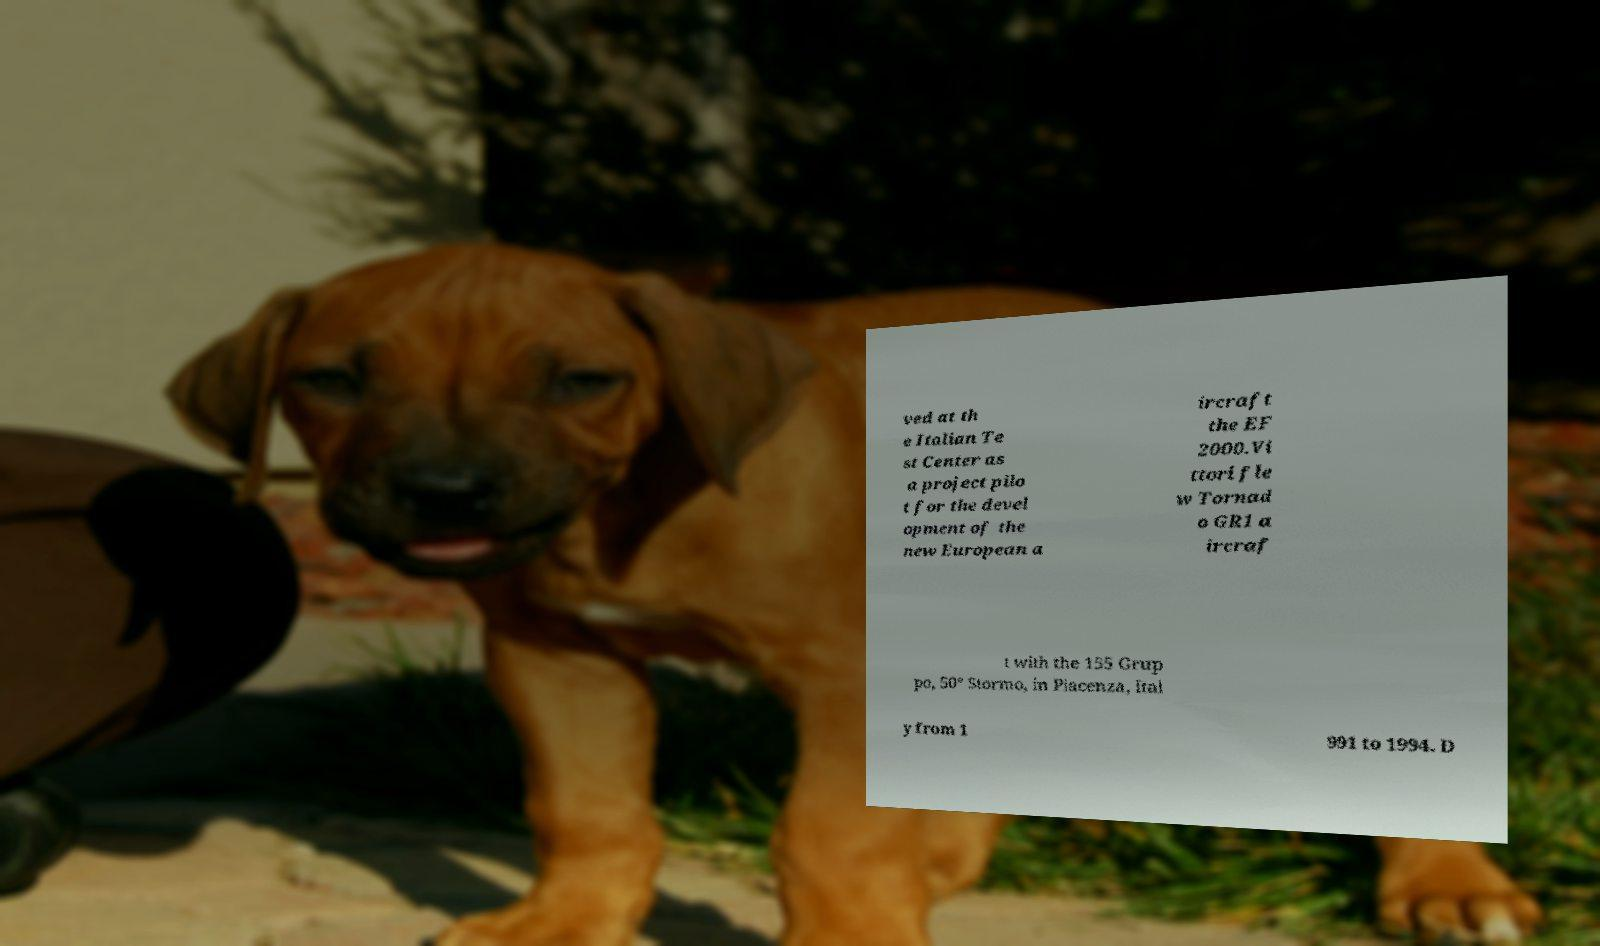Can you read and provide the text displayed in the image?This photo seems to have some interesting text. Can you extract and type it out for me? ved at th e Italian Te st Center as a project pilo t for the devel opment of the new European a ircraft the EF 2000.Vi ttori fle w Tornad o GR1 a ircraf t with the 155 Grup po, 50° Stormo, in Piacenza, Ital y from 1 991 to 1994. D 